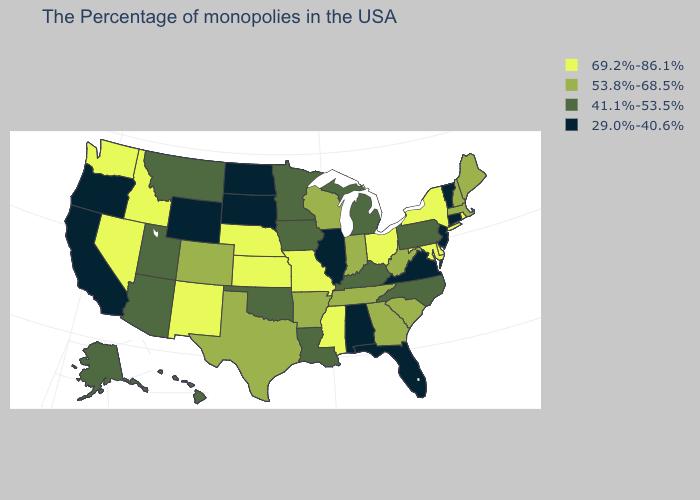What is the value of New Mexico?
Write a very short answer. 69.2%-86.1%. Name the states that have a value in the range 29.0%-40.6%?
Concise answer only. Vermont, Connecticut, New Jersey, Virginia, Florida, Alabama, Illinois, South Dakota, North Dakota, Wyoming, California, Oregon. Does Mississippi have the highest value in the USA?
Be succinct. Yes. What is the value of Virginia?
Be succinct. 29.0%-40.6%. Does Alabama have the lowest value in the USA?
Keep it brief. Yes. Name the states that have a value in the range 69.2%-86.1%?
Concise answer only. Rhode Island, New York, Delaware, Maryland, Ohio, Mississippi, Missouri, Kansas, Nebraska, New Mexico, Idaho, Nevada, Washington. Is the legend a continuous bar?
Short answer required. No. How many symbols are there in the legend?
Short answer required. 4. How many symbols are there in the legend?
Answer briefly. 4. How many symbols are there in the legend?
Answer briefly. 4. Is the legend a continuous bar?
Answer briefly. No. Among the states that border Missouri , does Kansas have the lowest value?
Write a very short answer. No. Does Rhode Island have a higher value than New Mexico?
Short answer required. No. What is the highest value in the Northeast ?
Give a very brief answer. 69.2%-86.1%. 